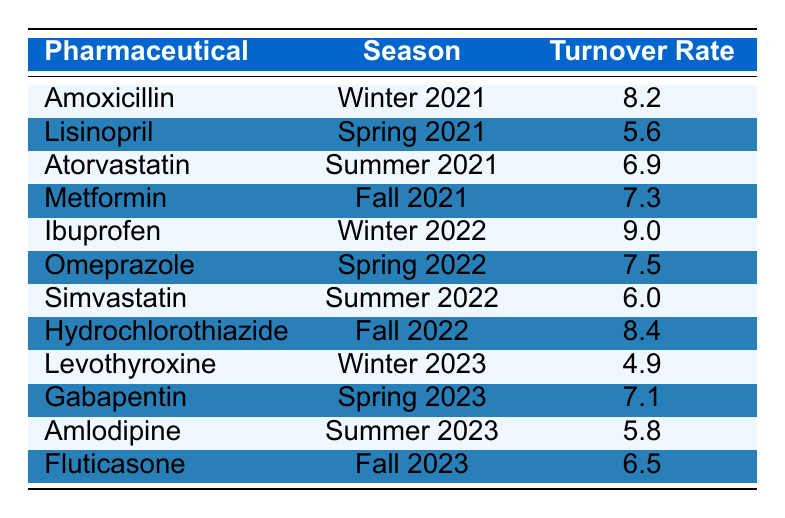What is the turnover rate for Ibuprofen in Winter 2022? The table lists Ibuprofen under the Winter 2022 season with a turnover rate of 9.0.
Answer: 9.0 Which pharmaceutical had the highest turnover rate in Fall 2022? The table shows Hydrochlorothiazide in Fall 2022 with a turnover rate of 8.4, which is higher than other pharmaceuticals listed for that season.
Answer: Hydrochlorothiazide What is the average turnover rate for the pharmaceuticals in Winter across all years? The turnover rates for Winter are: 8.2 (Winter 2021), 9.0 (Winter 2022), and 4.9 (Winter 2023). Summing these gives 8.2 + 9.0 + 4.9 = 22.1. The average is 22.1/3 = 7.37.
Answer: 7.37 Did the turnover rate for Levothyroxine increase from Winter 2022 to Winter 2023? Levothyroxine’s turnover rate in Winter 2022 is not specified, but the rate for Winter 2023 is 4.9. Comparing these numbers indicates that Levothyroxine experienced a decrease.
Answer: No Which season had the lowest average turnover rate across the pharmaceuticals listed? Looking at the turnover rates: Winter 2021 (8.2), Spring 2021 (5.6), Summer 2021 (6.9), Fall 2021 (7.3), Winter 2022 (9.0), Spring 2022 (7.5), Summer 2022 (6.0), Fall 2022 (8.4), Winter 2023 (4.9), Spring 2023 (7.1), Summer 2023 (5.8), and Fall 2023 (6.5). Winter 2023 has the lowest turnover rate of 4.9.
Answer: Winter 2023 What was the turnover rate for Amlodipine in Summer 2023 compared to that of Lisinopril in Spring 2021? The turnover rate for Amlodipine in Summer 2023 is 5.8, while Lisinopril in Spring 2021 has a turnover rate of 5.6. Therefore, Amlodipine in Summer 2023 has a higher turnover rate.
Answer: Amlodipine is higher How many pharmaceuticals had a turnover rate of 6.0 or less across the recorded seasons? The table shows Simvastatin (6.0), Lisinopril (5.6), Amlodipine (5.8), and Levothyroxine (4.9) which gives a total of four pharmaceuticals.
Answer: Four Was Gabapentin's turnover rate higher or lower than Atorvastatin's in Summer 2021? Gabapentin in Spring 2023 has a turnover rate of 7.1 compared to Atorvastatin's 6.9 in Summer 2021, indicating that Gabapentin's rate is higher.
Answer: Higher Which pharmaceutical showed an increase in turnover rate from Spring 2022 to Spring 2023? Omeprazole had a turnover rate of 7.5 in Spring 2022, while Gabapentin had 7.1 in Spring 2023. Since Gabapentin's rate is lower, thus there is no increase.
Answer: No increase 